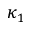<formula> <loc_0><loc_0><loc_500><loc_500>\kappa _ { 1 }</formula> 